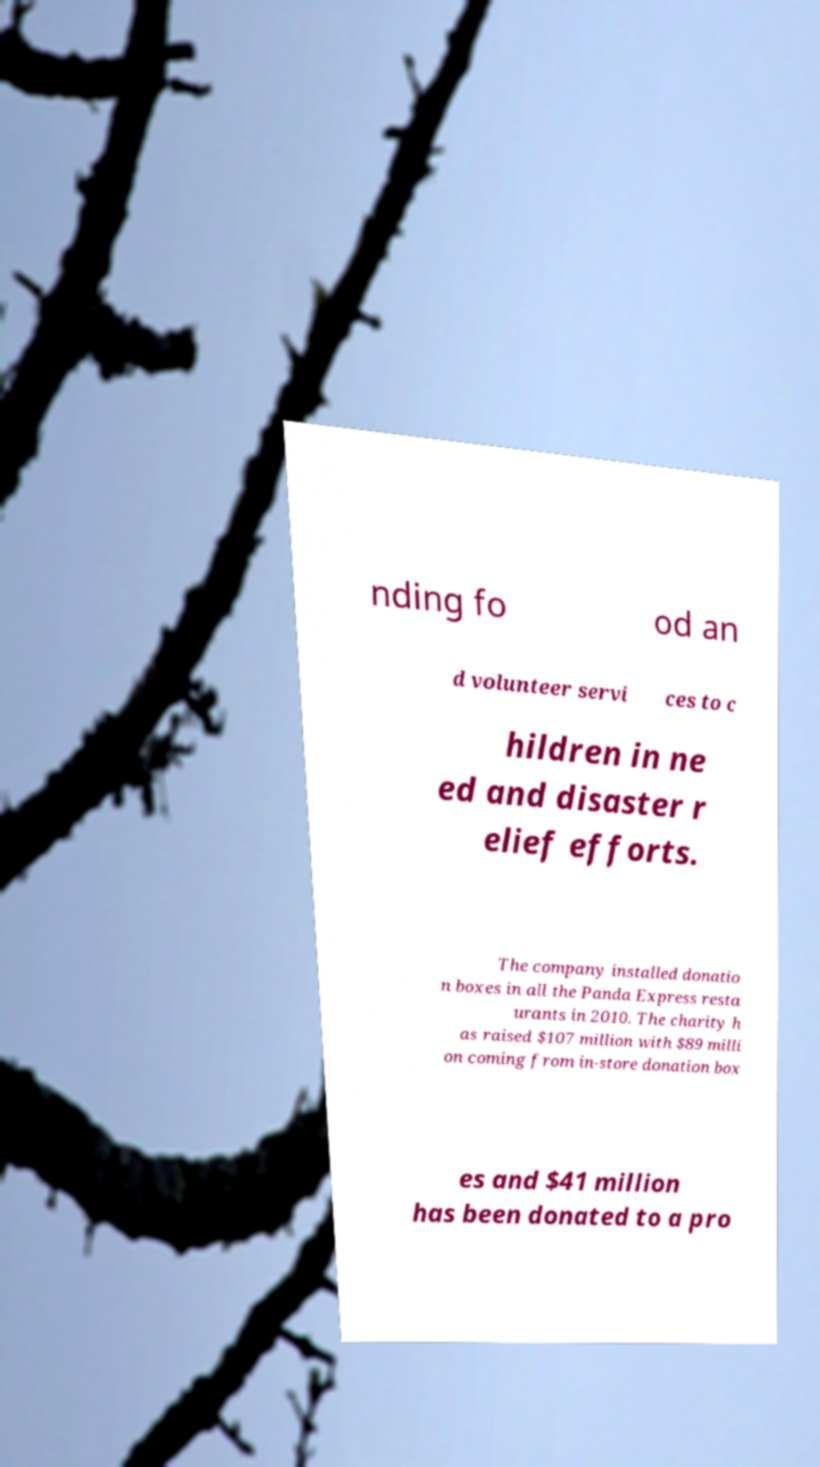Could you extract and type out the text from this image? nding fo od an d volunteer servi ces to c hildren in ne ed and disaster r elief efforts. The company installed donatio n boxes in all the Panda Express resta urants in 2010. The charity h as raised $107 million with $89 milli on coming from in-store donation box es and $41 million has been donated to a pro 